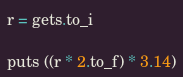<code> <loc_0><loc_0><loc_500><loc_500><_Ruby_>r = gets.to_i
 
puts ((r * 2.to_f) * 3.14)</code> 